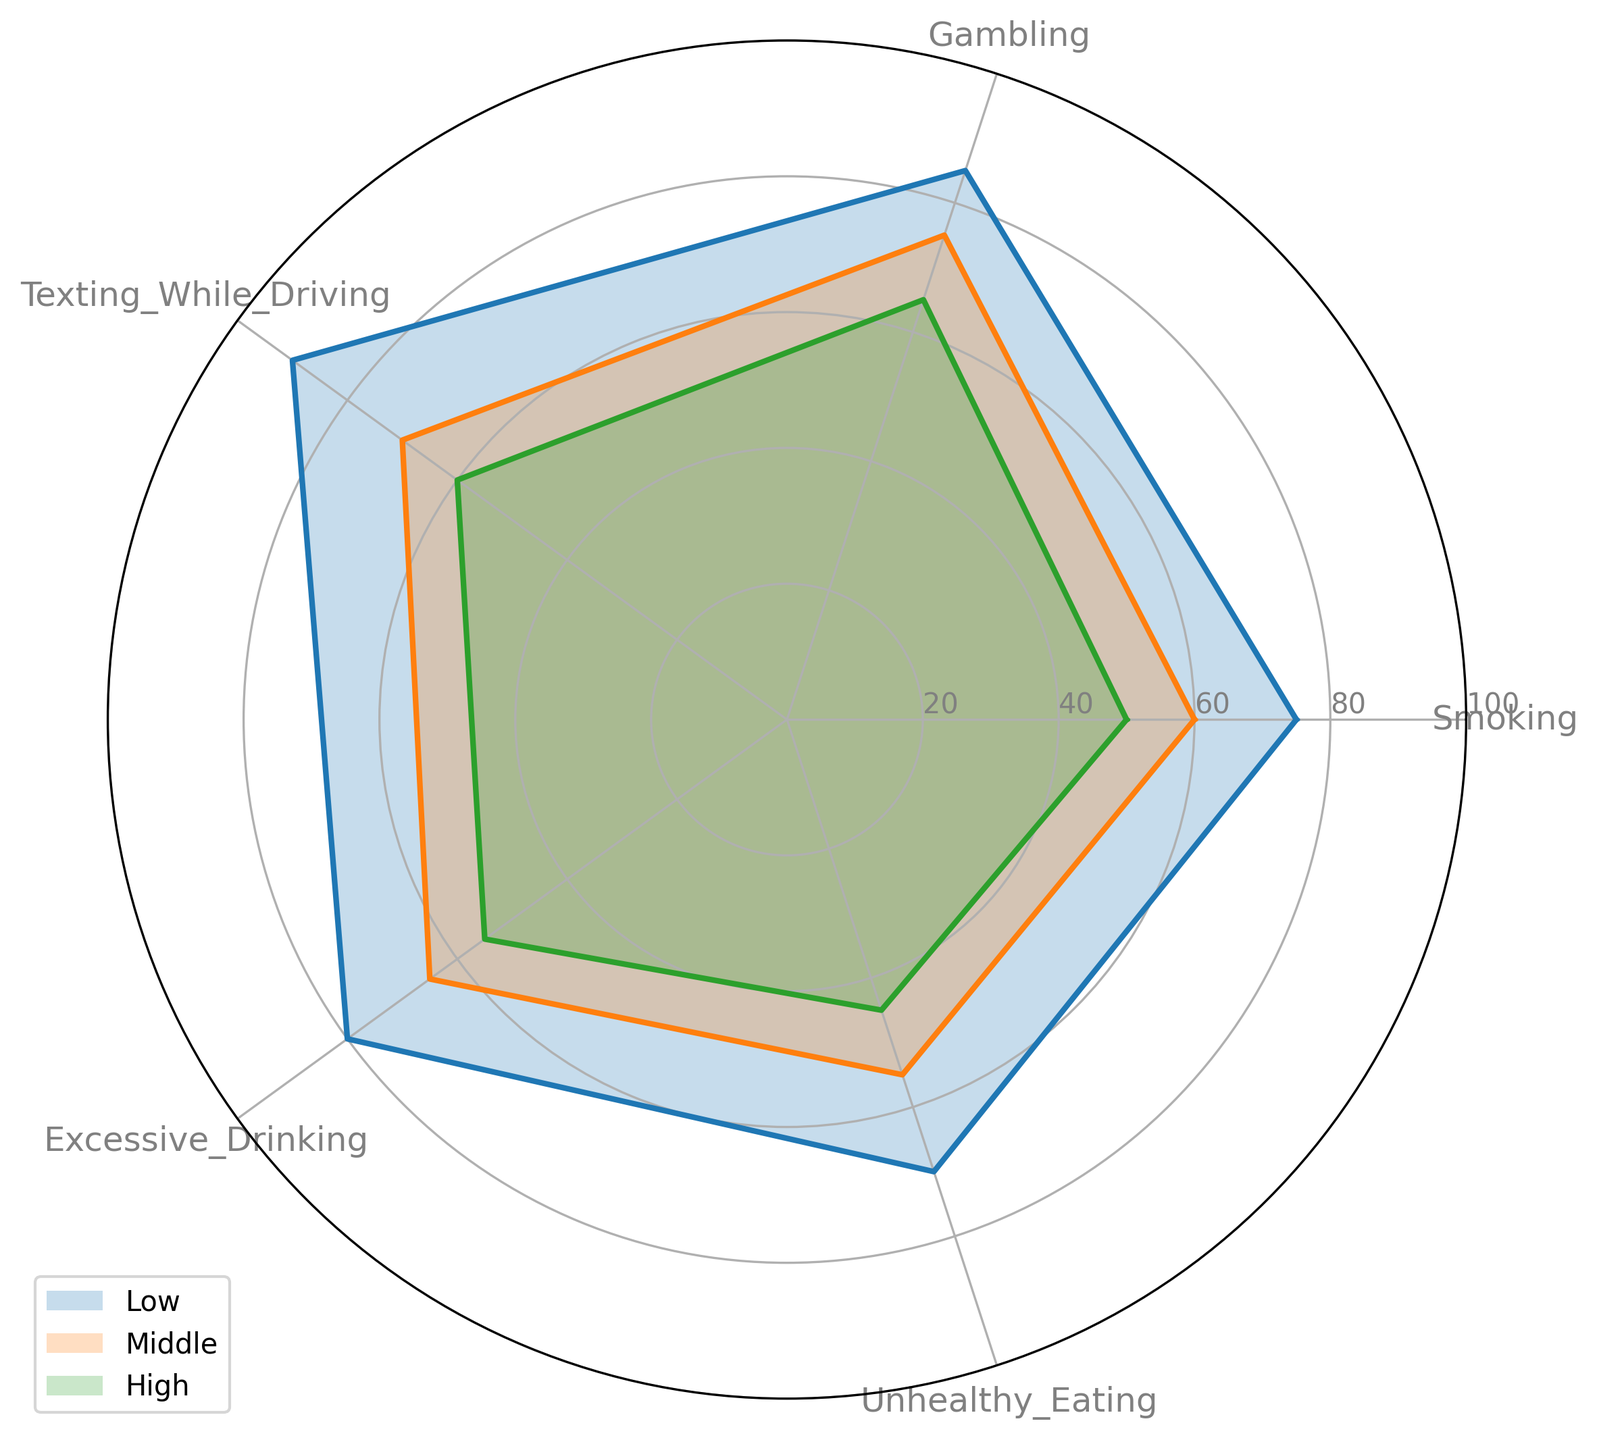Which socioeconomic status perceives the highest risk for gambling? Looking at the separate lines for each socioeconomic status in the radar chart, the line representing "Low" is the furthest from the center for gambling, indicating the highest perceived risk.
Answer: Low Which behavior shows the smallest perceived risk across all socioeconomic statuses? By comparing the positions of the lines in the radar chart, it's clear that the segment for "Unhealthy Eating" has the lowest values across the board—especially for the "High" socioeconomic status.
Answer: Unhealthy Eating What is the difference in perceived risk of smoking between the high and low socioeconomic statuses? The radar chart indicates that the perceived risk for smoking is at 75 for the low socioeconomic status and 50 for the high socioeconomic status. Subtracting those values gives the difference. 75 - 50 = 25
Answer: 25 Which irrational behavior has the greatest difference in perceived risk between the low and high socioeconomic statuses? Calculate the difference in perceived risks for each behavior: Smoking (25), Gambling (20), Texting While Driving (30), Excessive Drinking (25), and Unhealthy Eating (25). Texting While Driving has the highest difference at 30.
Answer: Texting While Driving What is the average perceived risk of excessive drinking for all socioeconomic statuses? Adding up the perceived risks of excessive drinking for low (80), middle (65), and high (55) and then dividing by the number of statuses, we get (80 + 65 + 55) / 3 = 200 / 3 ≈ 66.67
Answer: 66.67 Which behavior exhibits the most consistent perceived risk across all socioeconomic statuses? The consistency of perceived risk can be seen by finding the behavior with the smallest range in values: Smoking (75-50=25), Gambling (85-65=20), Texting While Driving (90-60=30), Excessive Drinking (80-55=25), Unhealthy Eating (70-45=25). Gambling has the smallest range at 20.
Answer: Gambling Do all socioeconomic statuses consider texting while driving riskier than unhealthy eating? By observing the radar chart, all the segments for Texting While Driving are further from the center compared to Unhealthy Eating, indicating higher perceived risks for Texting While Driving across all statuses.
Answer: Yes What is the combined perceived risk for gambling and unhealthy eating for the middle socioeconomic status? Adding the perceived risk values for gambling (75) and unhealthy eating (55) for the middle socioeconomic status gives 75 + 55 = 130.
Answer: 130 